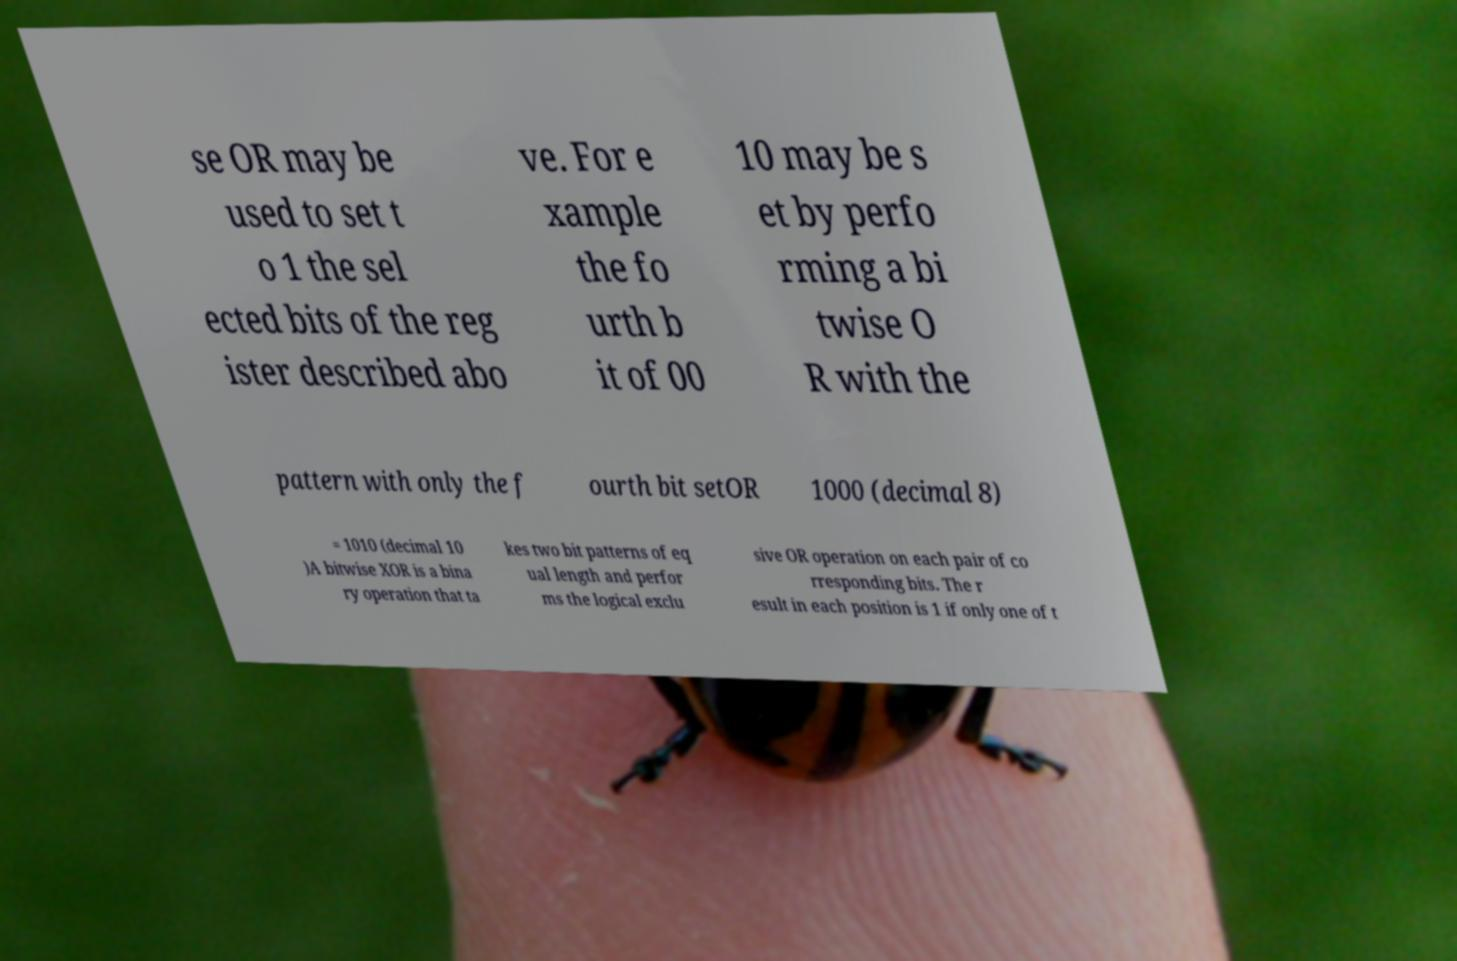Can you accurately transcribe the text from the provided image for me? se OR may be used to set t o 1 the sel ected bits of the reg ister described abo ve. For e xample the fo urth b it of 00 10 may be s et by perfo rming a bi twise O R with the pattern with only the f ourth bit setOR 1000 (decimal 8) = 1010 (decimal 10 )A bitwise XOR is a bina ry operation that ta kes two bit patterns of eq ual length and perfor ms the logical exclu sive OR operation on each pair of co rresponding bits. The r esult in each position is 1 if only one of t 